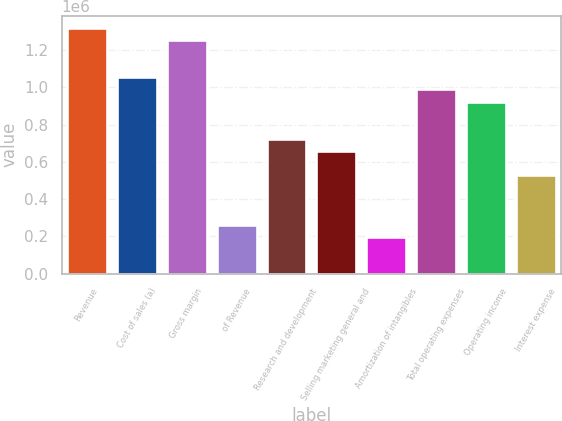Convert chart. <chart><loc_0><loc_0><loc_500><loc_500><bar_chart><fcel>Revenue<fcel>Cost of sales (a)<fcel>Gross margin<fcel>of Revenue<fcel>Research and development<fcel>Selling marketing general and<fcel>Amortization of intangibles<fcel>Total operating expenses<fcel>Operating income<fcel>Interest expense<nl><fcel>1.3185e+06<fcel>1.0548e+06<fcel>1.25257e+06<fcel>263700<fcel>725175<fcel>659250<fcel>197775<fcel>988875<fcel>922950<fcel>527400<nl></chart> 